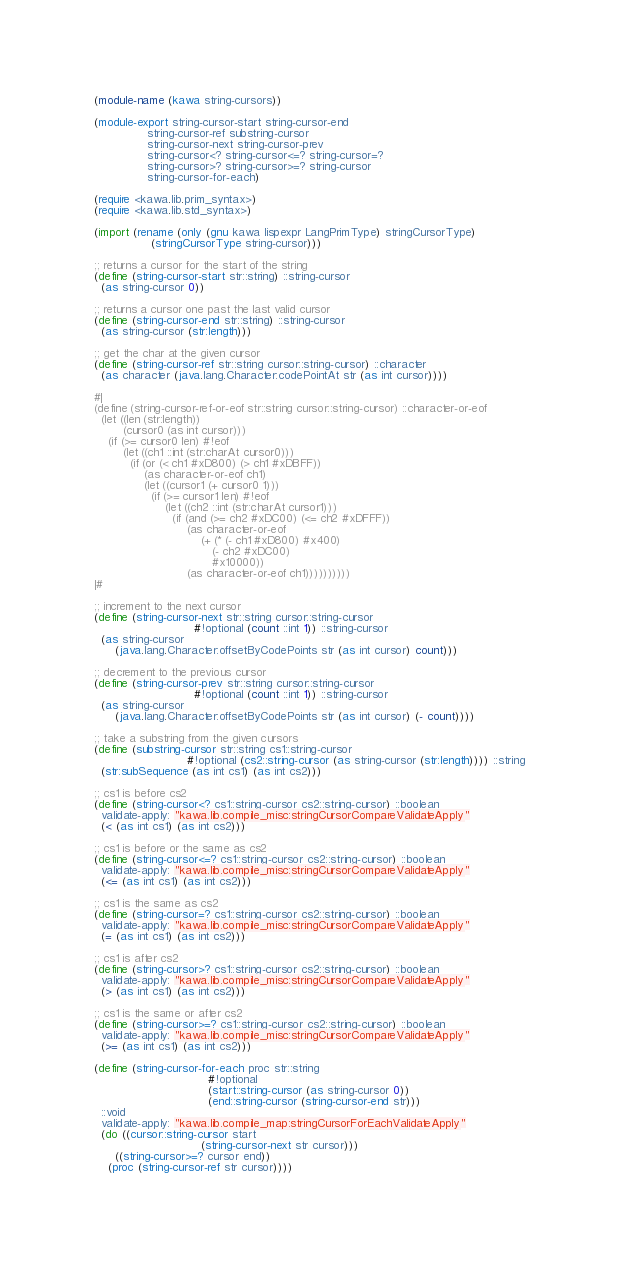<code> <loc_0><loc_0><loc_500><loc_500><_Scheme_>(module-name (kawa string-cursors))

(module-export string-cursor-start string-cursor-end
               string-cursor-ref substring-cursor
               string-cursor-next string-cursor-prev
               string-cursor<? string-cursor<=? string-cursor=?
               string-cursor>? string-cursor>=? string-cursor
               string-cursor-for-each)

(require <kawa.lib.prim_syntax>)
(require <kawa.lib.std_syntax>)

(import (rename (only (gnu kawa lispexpr LangPrimType) stringCursorType)
                (stringCursorType string-cursor)))

;; returns a cursor for the start of the string
(define (string-cursor-start str::string) ::string-cursor
  (as string-cursor 0))

;; returns a cursor one past the last valid cursor
(define (string-cursor-end str::string) ::string-cursor
  (as string-cursor (str:length)))

;; get the char at the given cursor
(define (string-cursor-ref str::string cursor::string-cursor) ::character
  (as character (java.lang.Character:codePointAt str (as int cursor))))

#|
(define (string-cursor-ref-or-eof str::string cursor::string-cursor) ::character-or-eof
  (let ((len (str:length))
        (cursor0 (as int cursor)))
    (if (>= cursor0 len) #!eof
        (let ((ch1 ::int (str:charAt cursor0)))
          (if (or (< ch1 #xD800) (> ch1 #xDBFF))
              (as character-or-eof ch1)
              (let ((cursor1 (+ cursor0 1)))
                (if (>= cursor1 len) #!eof
                    (let ((ch2 ::int (str:charAt cursor1)))
                      (if (and (>= ch2 #xDC00) (<= ch2 #xDFFF))
                          (as character-or-eof 
                              (+ (* (- ch1 #xD800) #x400)
                                 (- ch2 #xDC00)
                                 #x10000))
                          (as character-or-eof ch1))))))))))
|#

;; increment to the next cursor
(define (string-cursor-next str::string cursor::string-cursor
                            #!optional (count ::int 1)) ::string-cursor
  (as string-cursor
      (java.lang.Character:offsetByCodePoints str (as int cursor) count)))

;; decrement to the previous cursor
(define (string-cursor-prev str::string cursor::string-cursor
                            #!optional (count ::int 1)) ::string-cursor
  (as string-cursor
      (java.lang.Character:offsetByCodePoints str (as int cursor) (- count))))

;; take a substring from the given cursors
(define (substring-cursor str::string cs1::string-cursor
                          #!optional (cs2::string-cursor (as string-cursor (str:length)))) ::string
  (str:subSequence (as int cs1) (as int cs2)))

;; cs1 is before cs2
(define (string-cursor<? cs1::string-cursor cs2::string-cursor) ::boolean
  validate-apply: "kawa.lib.compile_misc:stringCursorCompareValidateApply"
  (< (as int cs1) (as int cs2)))

;; cs1 is before or the same as cs2
(define (string-cursor<=? cs1::string-cursor cs2::string-cursor) ::boolean
  validate-apply: "kawa.lib.compile_misc:stringCursorCompareValidateApply"
  (<= (as int cs1) (as int cs2)))

;; cs1 is the same as cs2
(define (string-cursor=? cs1::string-cursor cs2::string-cursor) ::boolean
  validate-apply: "kawa.lib.compile_misc:stringCursorCompareValidateApply"
  (= (as int cs1) (as int cs2)))

;; cs1 is after cs2
(define (string-cursor>? cs1::string-cursor cs2::string-cursor) ::boolean
  validate-apply: "kawa.lib.compile_misc:stringCursorCompareValidateApply"
  (> (as int cs1) (as int cs2)))

;; cs1 is the same or after cs2
(define (string-cursor>=? cs1::string-cursor cs2::string-cursor) ::boolean
  validate-apply: "kawa.lib.compile_misc:stringCursorCompareValidateApply"
  (>= (as int cs1) (as int cs2)))

(define (string-cursor-for-each proc str::string
                                #!optional
                                (start::string-cursor (as string-cursor 0))
                                (end::string-cursor (string-cursor-end str)))
  ::void
  validate-apply: "kawa.lib.compile_map:stringCursorForEachValidateApply"
  (do ((cursor::string-cursor start
                              (string-cursor-next str cursor)))
      ((string-cursor>=? cursor end))
    (proc (string-cursor-ref str cursor))))
</code> 